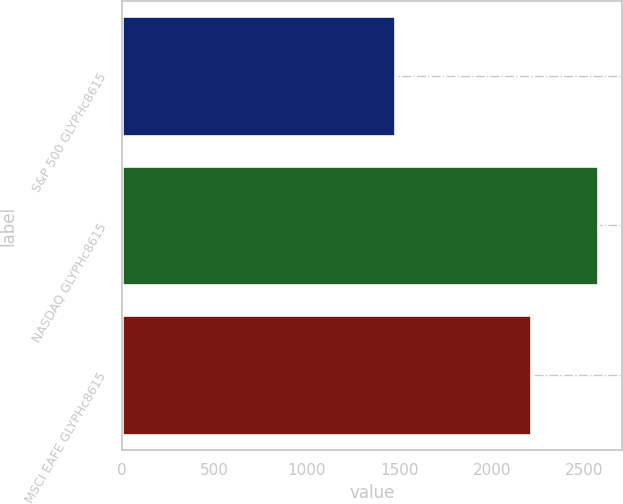Convert chart. <chart><loc_0><loc_0><loc_500><loc_500><bar_chart><fcel>S&P 500 GLYPHc8615<fcel>NASDAQ GLYPHc8615<fcel>MSCI EAFE GLYPHc8615<nl><fcel>1477<fcel>2578<fcel>2212<nl></chart> 